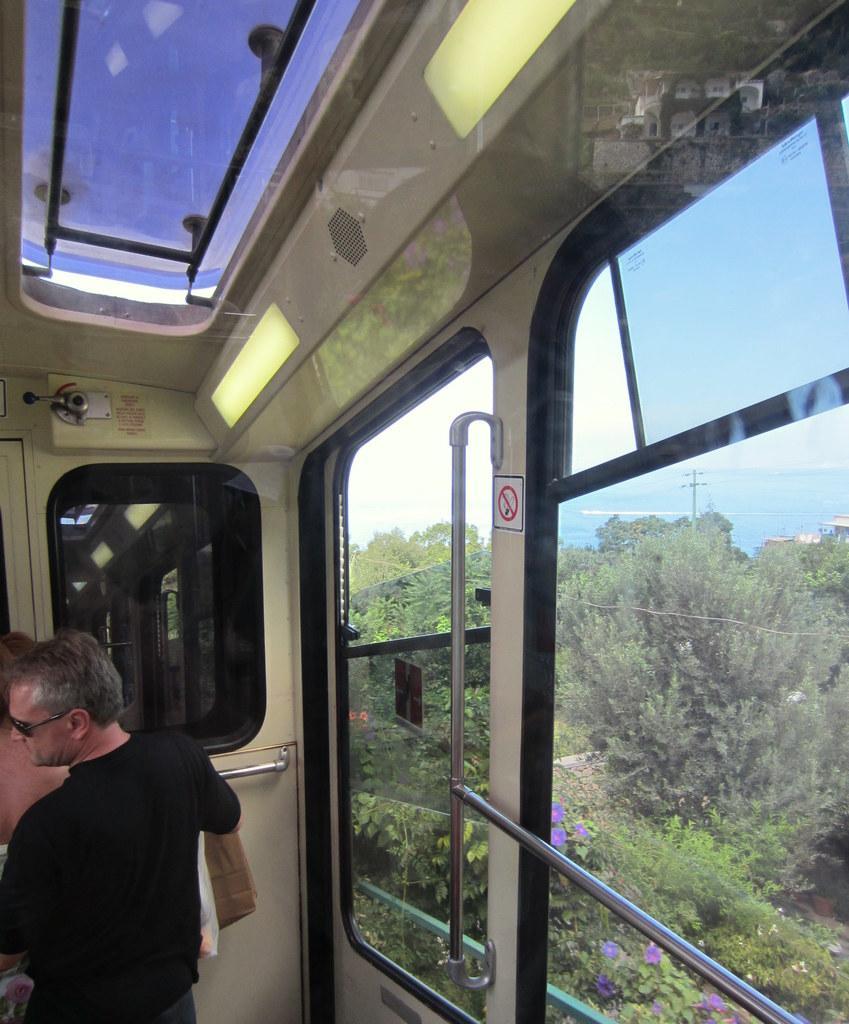Could you give a brief overview of what you see in this image? In this image, I can see two people standing. I think this picture was taken in the vehicle. These are the glass doors. I can see the handles. I can see the trees, sky and a pole through the glass door. 